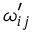Convert formula to latex. <formula><loc_0><loc_0><loc_500><loc_500>\omega _ { i j } ^ { \prime }</formula> 